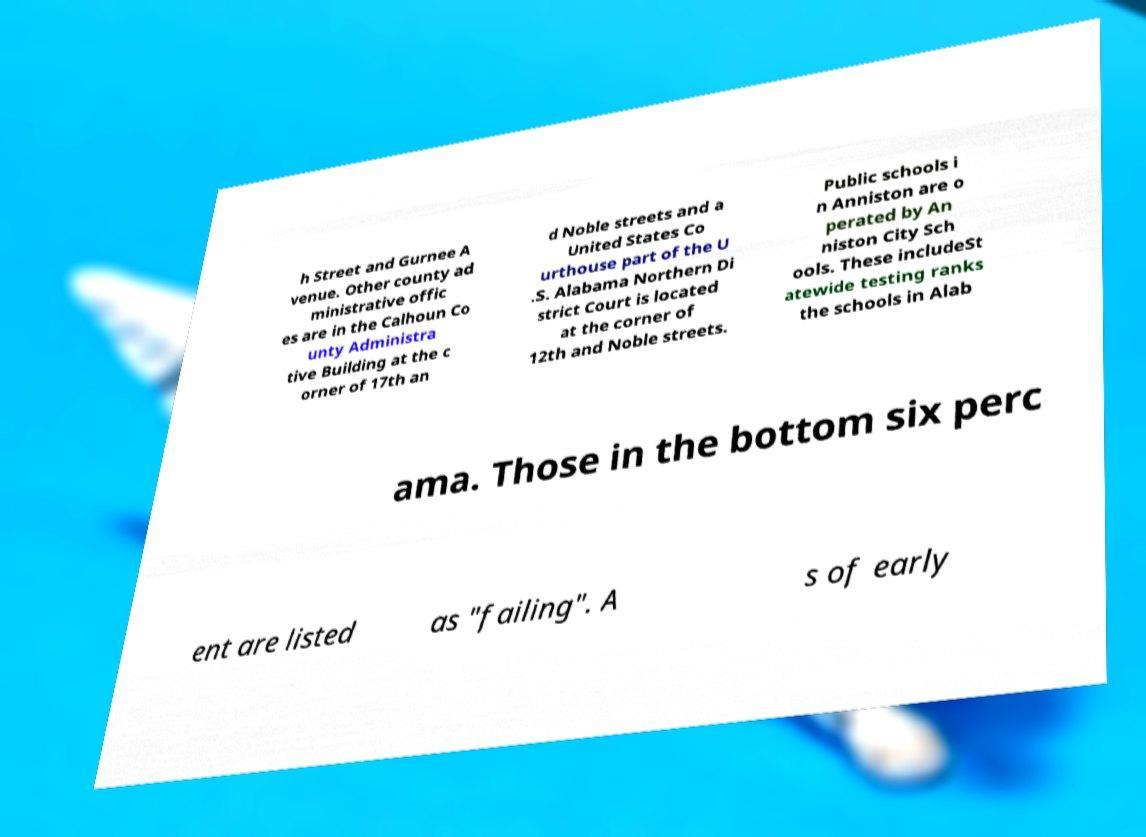For documentation purposes, I need the text within this image transcribed. Could you provide that? h Street and Gurnee A venue. Other county ad ministrative offic es are in the Calhoun Co unty Administra tive Building at the c orner of 17th an d Noble streets and a United States Co urthouse part of the U .S. Alabama Northern Di strict Court is located at the corner of 12th and Noble streets. Public schools i n Anniston are o perated by An niston City Sch ools. These includeSt atewide testing ranks the schools in Alab ama. Those in the bottom six perc ent are listed as "failing". A s of early 